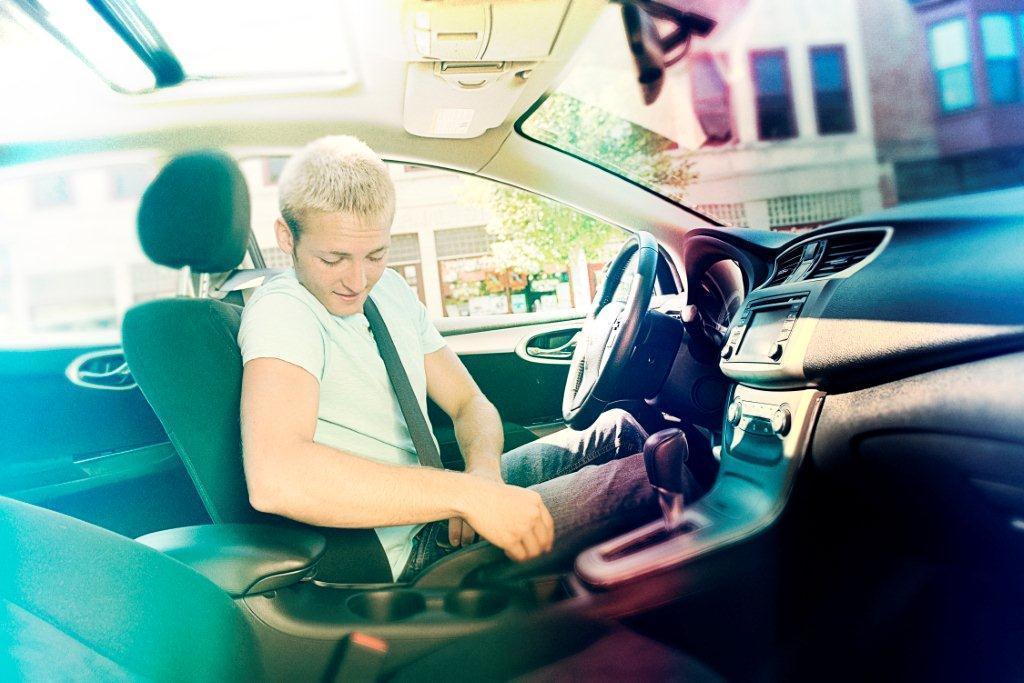Describe this image in one or two sentences. There is a man inside the car. This is steering and this is seat. And there is a building and this is tree. 